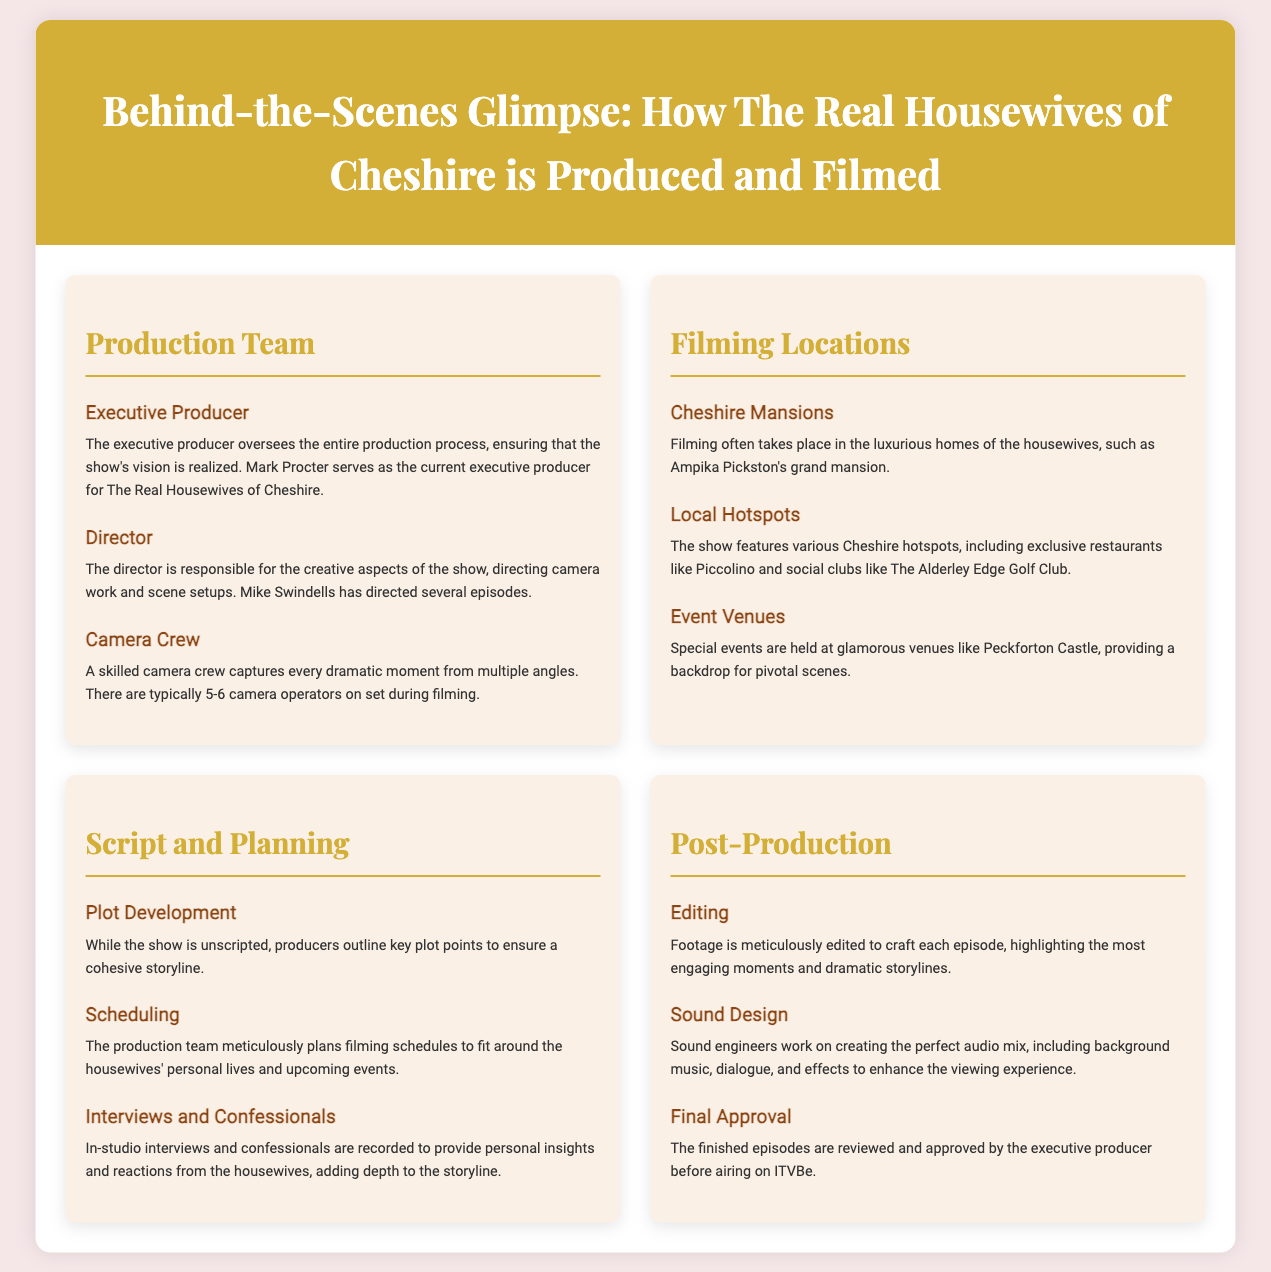What is the name of the executive producer? The document states that Mark Procter serves as the current executive producer for The Real Housewives of Cheshire.
Answer: Mark Procter How many camera operators are typically on set? According to the document, there are typically 5-6 camera operators on set during filming.
Answer: 5-6 Where are the filming locations mentioned? The document mentions filming in Cheshire Mansions, local hotspots, and event venues, highlighting specific locations like Ampika Pickston's mansion and Piccolino restaurant.
Answer: Cheshire Mansions, Local Hotspots, Event Venues What is the role of the director? The document describes the director as responsible for the creative aspects of the show, directing camera work and scene setups.
Answer: Creative aspects What does the production team do for plot development? The document indicates that while the show is unscripted, producers outline key plot points to ensure a cohesive storyline.
Answer: Outline key plot points What is recorded during interviews and confessionals? The document states that in-studio interviews and confessionals are recorded to provide personal insights and reactions from the housewives.
Answer: Personal insights and reactions What is the main focus during the editing process? According to the document, footage is meticulously edited to craft each episode, highlighting the most engaging moments and dramatic storylines.
Answer: Engaging moments Who must approve the finished episodes before airing? The document mentions that the finished episodes are reviewed and approved by the executive producer before airing on ITVBe.
Answer: Executive producer 